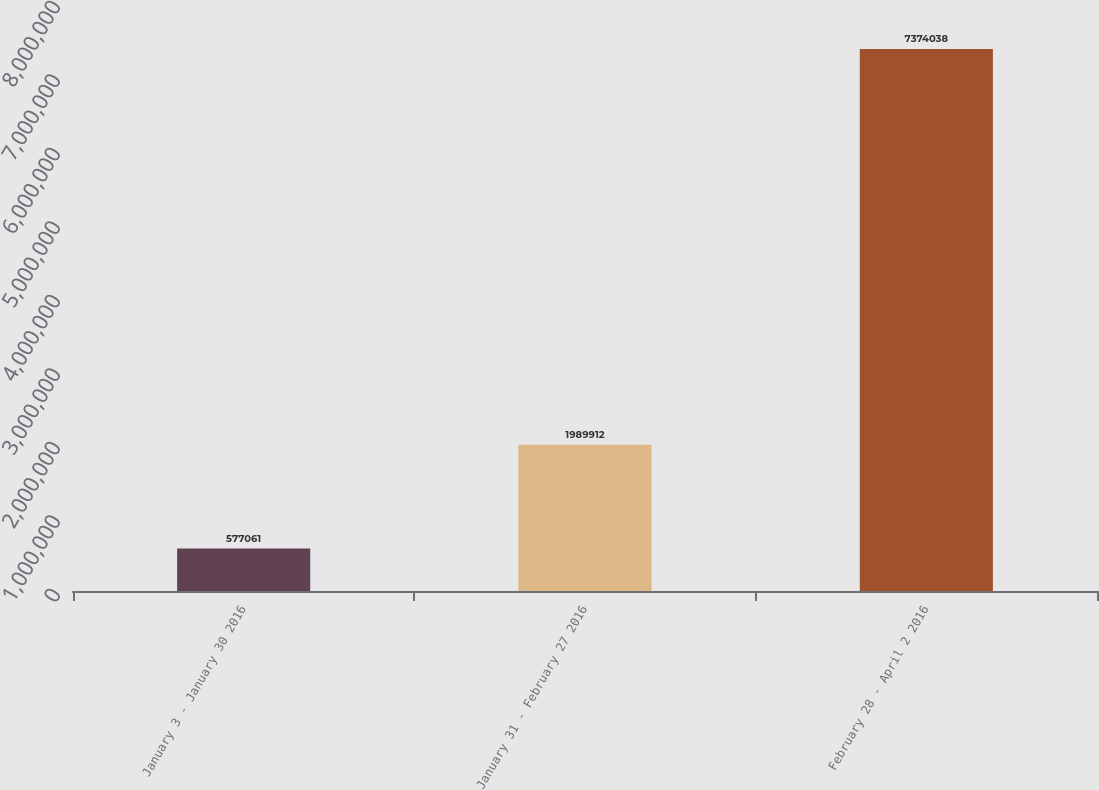Convert chart. <chart><loc_0><loc_0><loc_500><loc_500><bar_chart><fcel>January 3 - January 30 2016<fcel>January 31 - February 27 2016<fcel>February 28 - April 2 2016<nl><fcel>577061<fcel>1.98991e+06<fcel>7.37404e+06<nl></chart> 